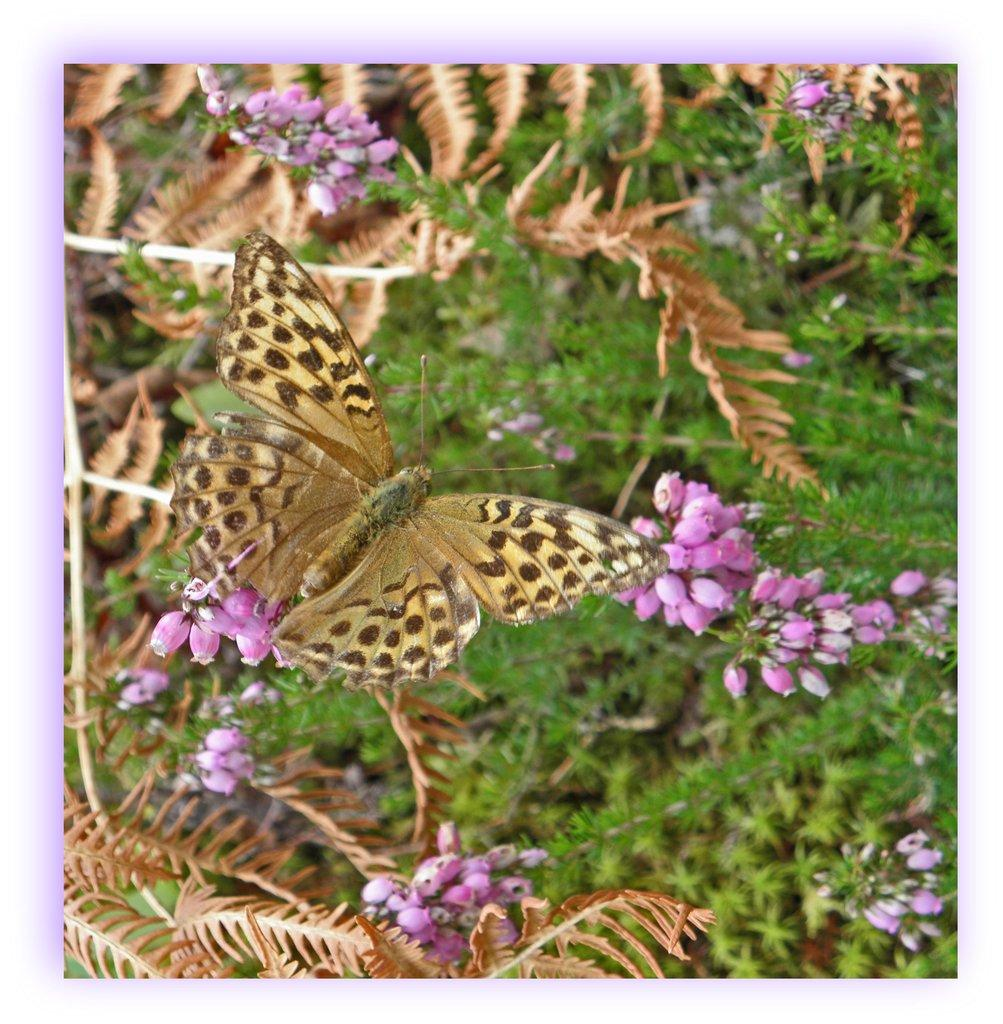What is the main subject in the center of the image? There is an insect in the center of the image. What can be seen in the background of the image? There are flowers and plants in the background of the image. What is the price of the horn in the image? There is no horn present in the image, so it is not possible to determine its price. 